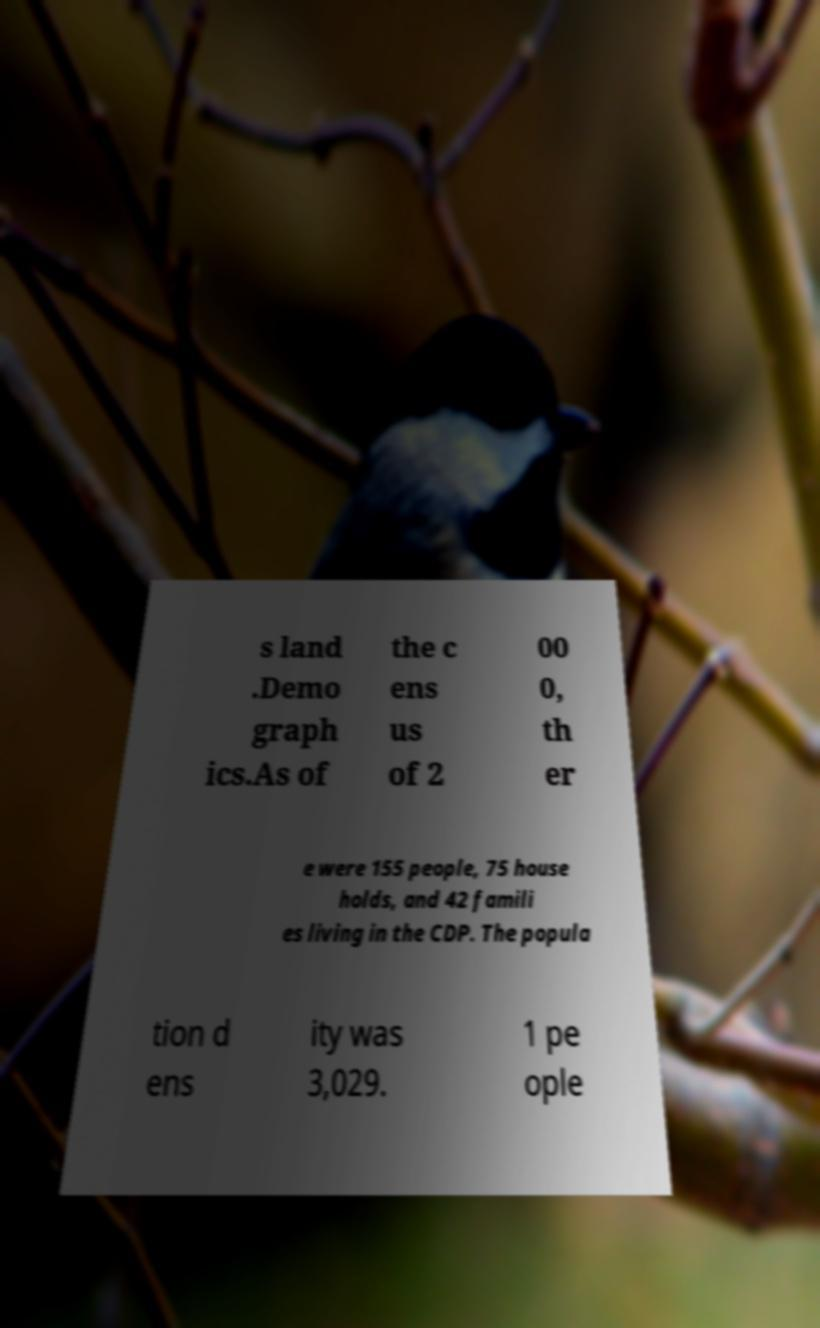Could you assist in decoding the text presented in this image and type it out clearly? s land .Demo graph ics.As of the c ens us of 2 00 0, th er e were 155 people, 75 house holds, and 42 famili es living in the CDP. The popula tion d ens ity was 3,029. 1 pe ople 